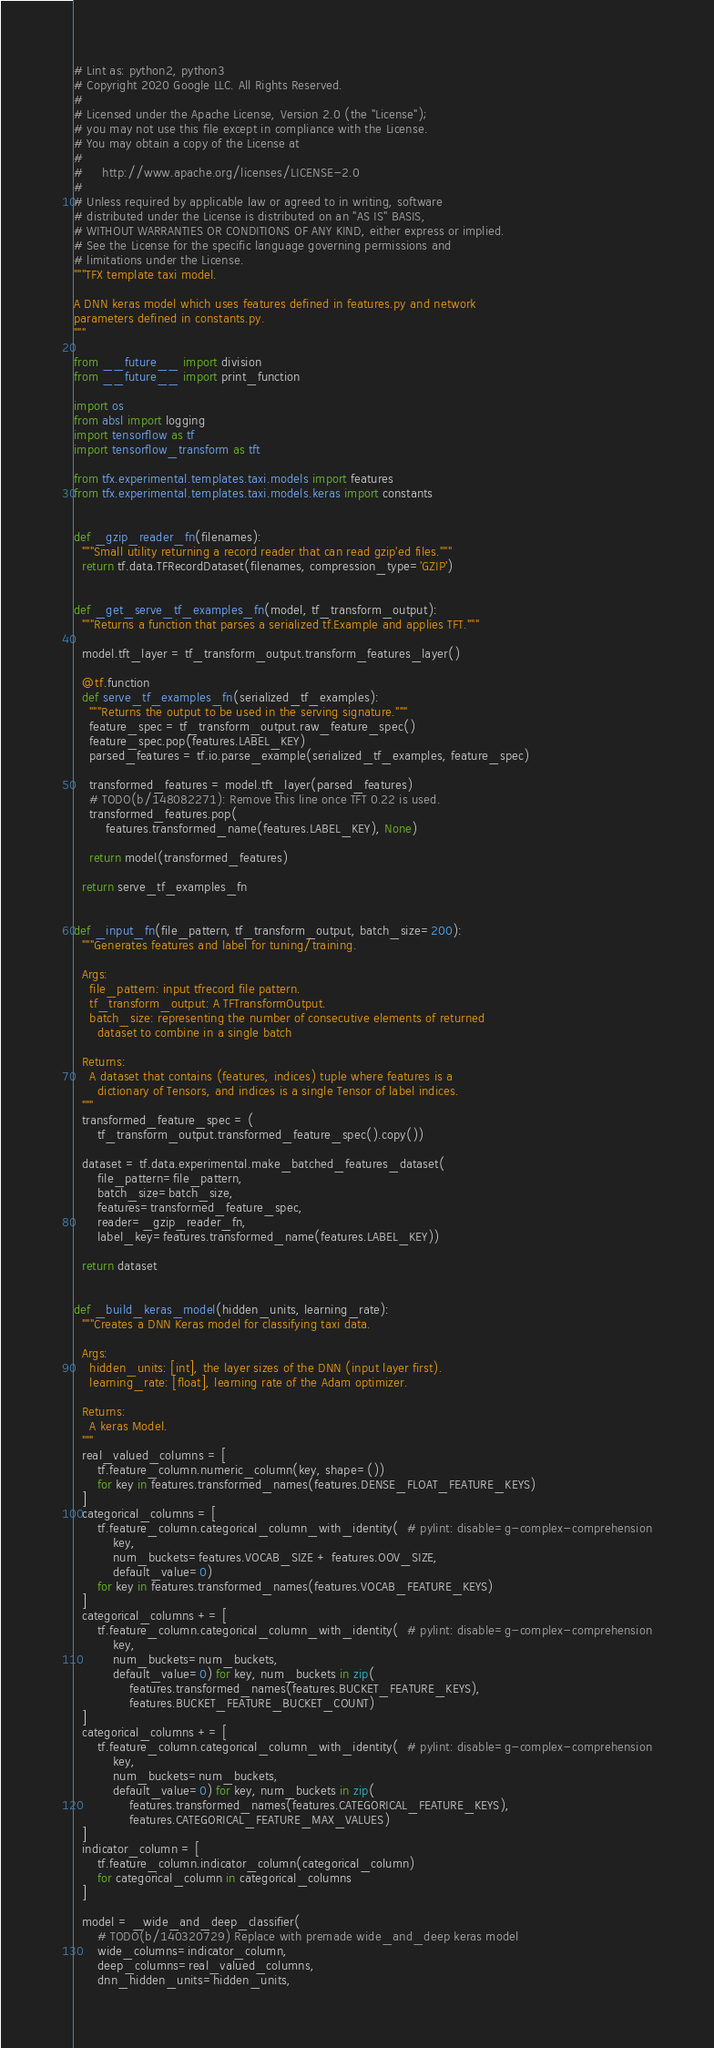<code> <loc_0><loc_0><loc_500><loc_500><_Python_># Lint as: python2, python3
# Copyright 2020 Google LLC. All Rights Reserved.
#
# Licensed under the Apache License, Version 2.0 (the "License");
# you may not use this file except in compliance with the License.
# You may obtain a copy of the License at
#
#     http://www.apache.org/licenses/LICENSE-2.0
#
# Unless required by applicable law or agreed to in writing, software
# distributed under the License is distributed on an "AS IS" BASIS,
# WITHOUT WARRANTIES OR CONDITIONS OF ANY KIND, either express or implied.
# See the License for the specific language governing permissions and
# limitations under the License.
"""TFX template taxi model.

A DNN keras model which uses features defined in features.py and network
parameters defined in constants.py.
"""

from __future__ import division
from __future__ import print_function

import os
from absl import logging
import tensorflow as tf
import tensorflow_transform as tft

from tfx.experimental.templates.taxi.models import features
from tfx.experimental.templates.taxi.models.keras import constants


def _gzip_reader_fn(filenames):
  """Small utility returning a record reader that can read gzip'ed files."""
  return tf.data.TFRecordDataset(filenames, compression_type='GZIP')


def _get_serve_tf_examples_fn(model, tf_transform_output):
  """Returns a function that parses a serialized tf.Example and applies TFT."""

  model.tft_layer = tf_transform_output.transform_features_layer()

  @tf.function
  def serve_tf_examples_fn(serialized_tf_examples):
    """Returns the output to be used in the serving signature."""
    feature_spec = tf_transform_output.raw_feature_spec()
    feature_spec.pop(features.LABEL_KEY)
    parsed_features = tf.io.parse_example(serialized_tf_examples, feature_spec)

    transformed_features = model.tft_layer(parsed_features)
    # TODO(b/148082271): Remove this line once TFT 0.22 is used.
    transformed_features.pop(
        features.transformed_name(features.LABEL_KEY), None)

    return model(transformed_features)

  return serve_tf_examples_fn


def _input_fn(file_pattern, tf_transform_output, batch_size=200):
  """Generates features and label for tuning/training.

  Args:
    file_pattern: input tfrecord file pattern.
    tf_transform_output: A TFTransformOutput.
    batch_size: representing the number of consecutive elements of returned
      dataset to combine in a single batch

  Returns:
    A dataset that contains (features, indices) tuple where features is a
      dictionary of Tensors, and indices is a single Tensor of label indices.
  """
  transformed_feature_spec = (
      tf_transform_output.transformed_feature_spec().copy())

  dataset = tf.data.experimental.make_batched_features_dataset(
      file_pattern=file_pattern,
      batch_size=batch_size,
      features=transformed_feature_spec,
      reader=_gzip_reader_fn,
      label_key=features.transformed_name(features.LABEL_KEY))

  return dataset


def _build_keras_model(hidden_units, learning_rate):
  """Creates a DNN Keras model for classifying taxi data.

  Args:
    hidden_units: [int], the layer sizes of the DNN (input layer first).
    learning_rate: [float], learning rate of the Adam optimizer.

  Returns:
    A keras Model.
  """
  real_valued_columns = [
      tf.feature_column.numeric_column(key, shape=())
      for key in features.transformed_names(features.DENSE_FLOAT_FEATURE_KEYS)
  ]
  categorical_columns = [
      tf.feature_column.categorical_column_with_identity(  # pylint: disable=g-complex-comprehension
          key,
          num_buckets=features.VOCAB_SIZE + features.OOV_SIZE,
          default_value=0)
      for key in features.transformed_names(features.VOCAB_FEATURE_KEYS)
  ]
  categorical_columns += [
      tf.feature_column.categorical_column_with_identity(  # pylint: disable=g-complex-comprehension
          key,
          num_buckets=num_buckets,
          default_value=0) for key, num_buckets in zip(
              features.transformed_names(features.BUCKET_FEATURE_KEYS),
              features.BUCKET_FEATURE_BUCKET_COUNT)
  ]
  categorical_columns += [
      tf.feature_column.categorical_column_with_identity(  # pylint: disable=g-complex-comprehension
          key,
          num_buckets=num_buckets,
          default_value=0) for key, num_buckets in zip(
              features.transformed_names(features.CATEGORICAL_FEATURE_KEYS),
              features.CATEGORICAL_FEATURE_MAX_VALUES)
  ]
  indicator_column = [
      tf.feature_column.indicator_column(categorical_column)
      for categorical_column in categorical_columns
  ]

  model = _wide_and_deep_classifier(
      # TODO(b/140320729) Replace with premade wide_and_deep keras model
      wide_columns=indicator_column,
      deep_columns=real_valued_columns,
      dnn_hidden_units=hidden_units,</code> 